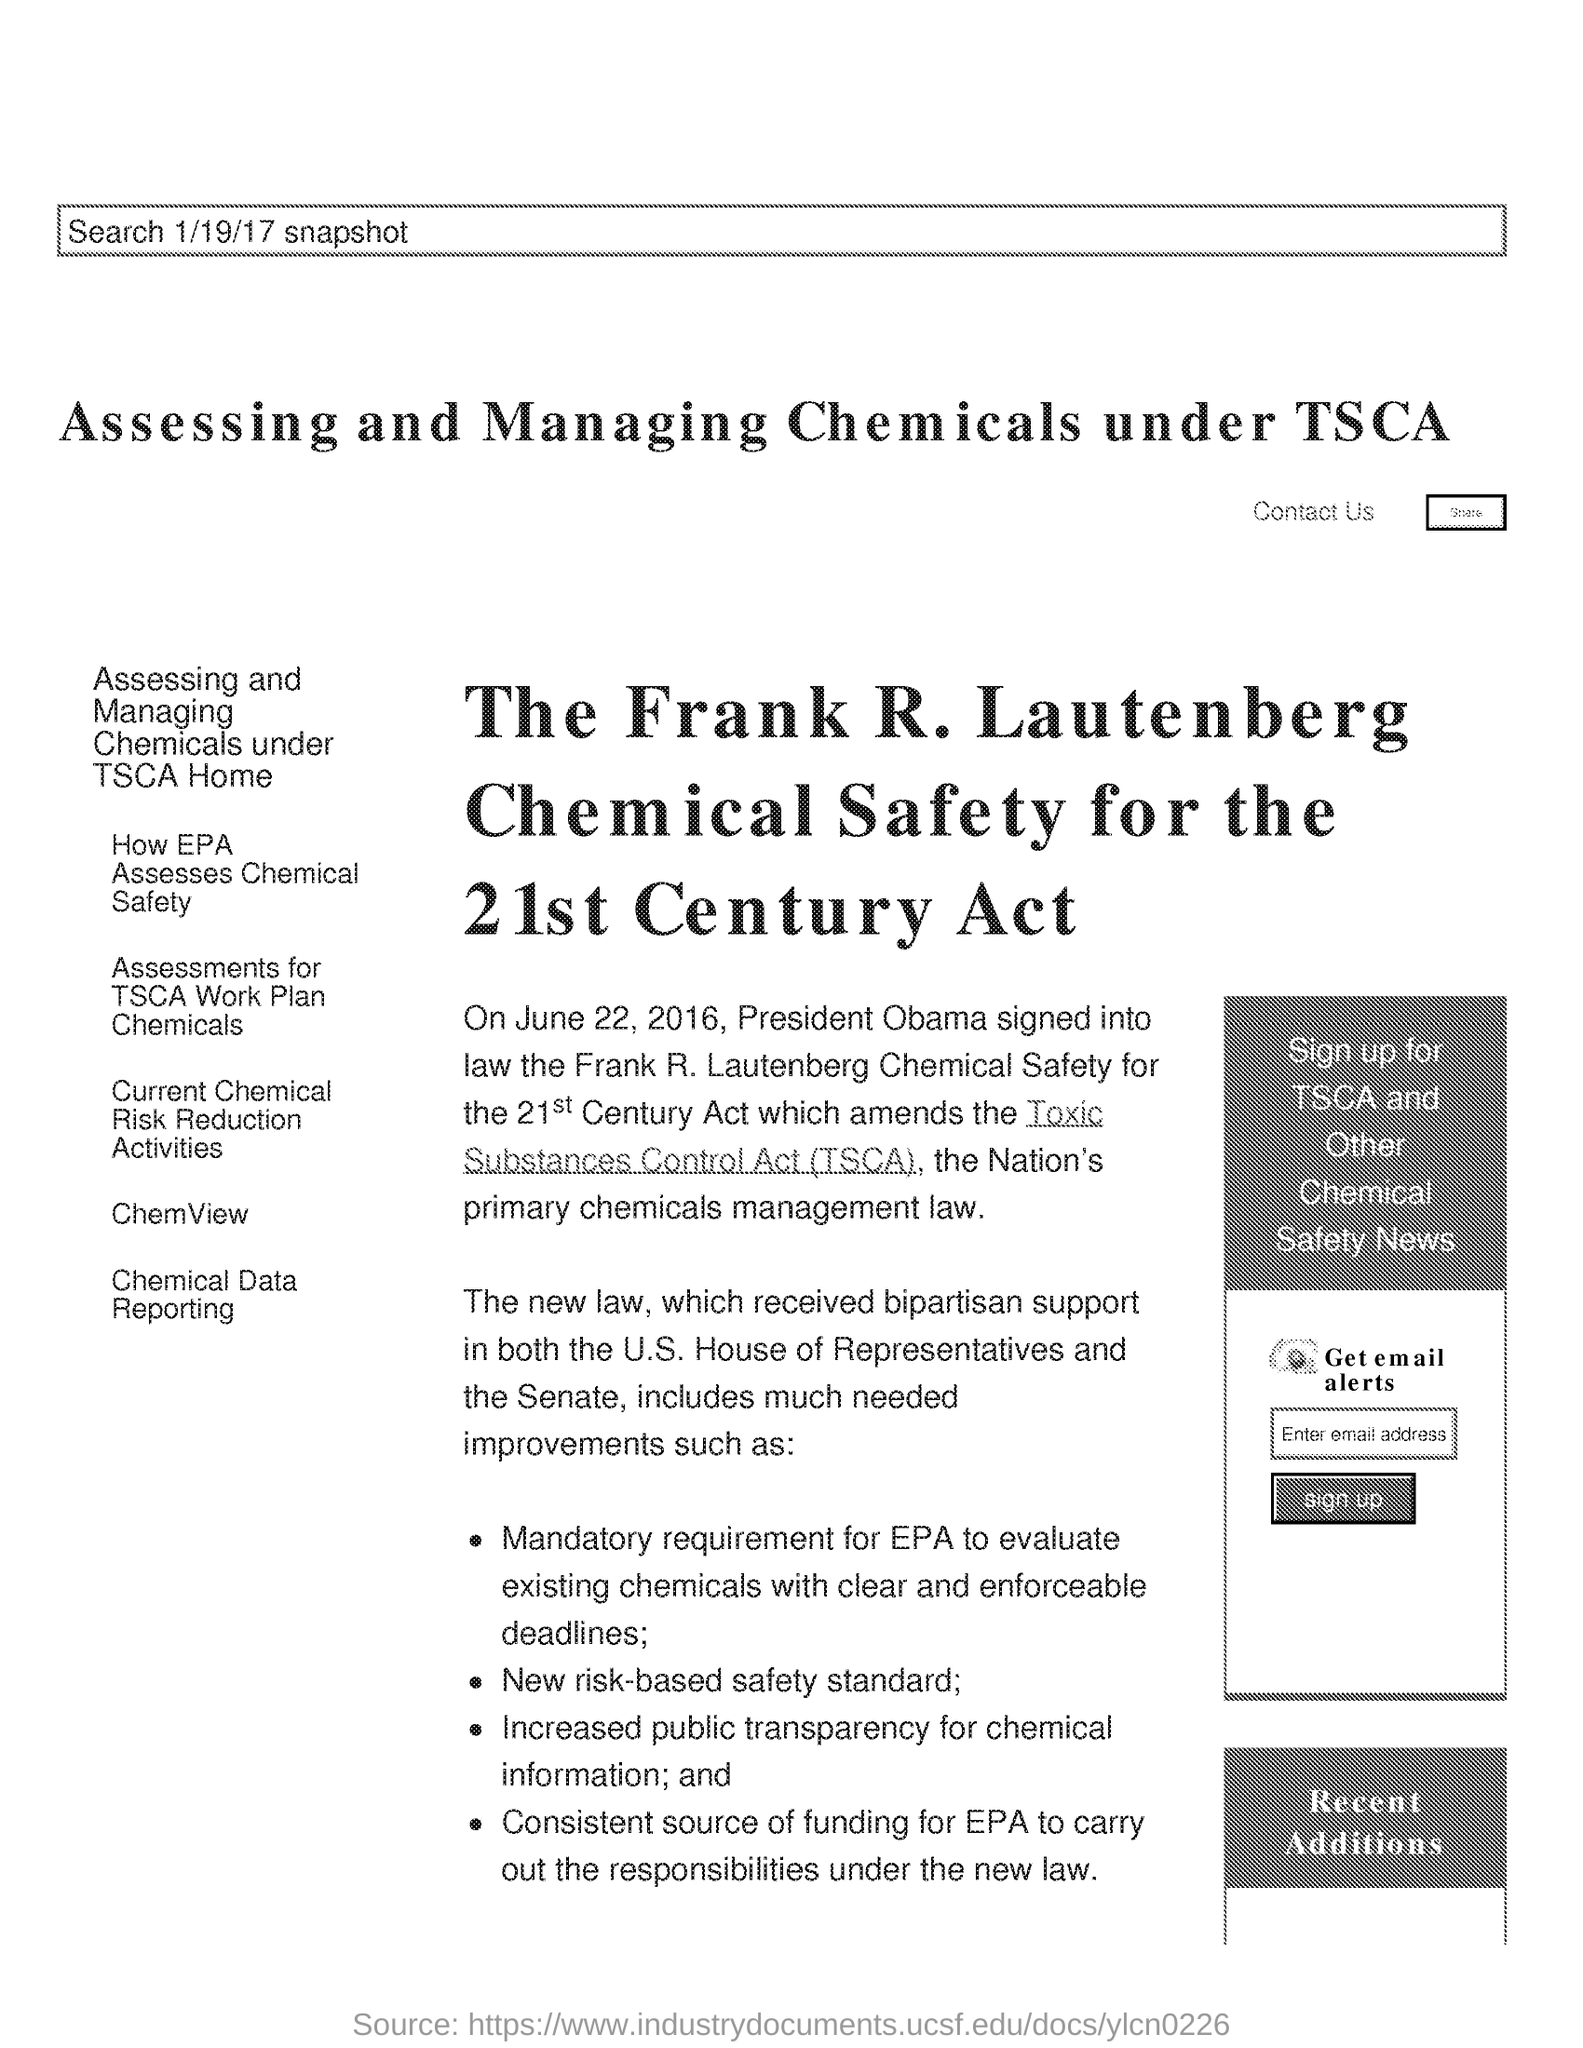Identify some key points in this picture. The Toxic Substances Control Act (TSCA) is a federal law that regulates the production, use, and disposal of toxic substances in the United States. I, President Obama, have signed the Frank R. Launtenberg Chemical Safety for 21st Century Act into law. The mandatory requirement for the Environmental Protection Agency (EPA) was to evaluate existing chemicals with clear and enforceable deadlines for evaluation. On June 22, 2016, President Obama amended the Toxic Substances Control Act (TSCA). 